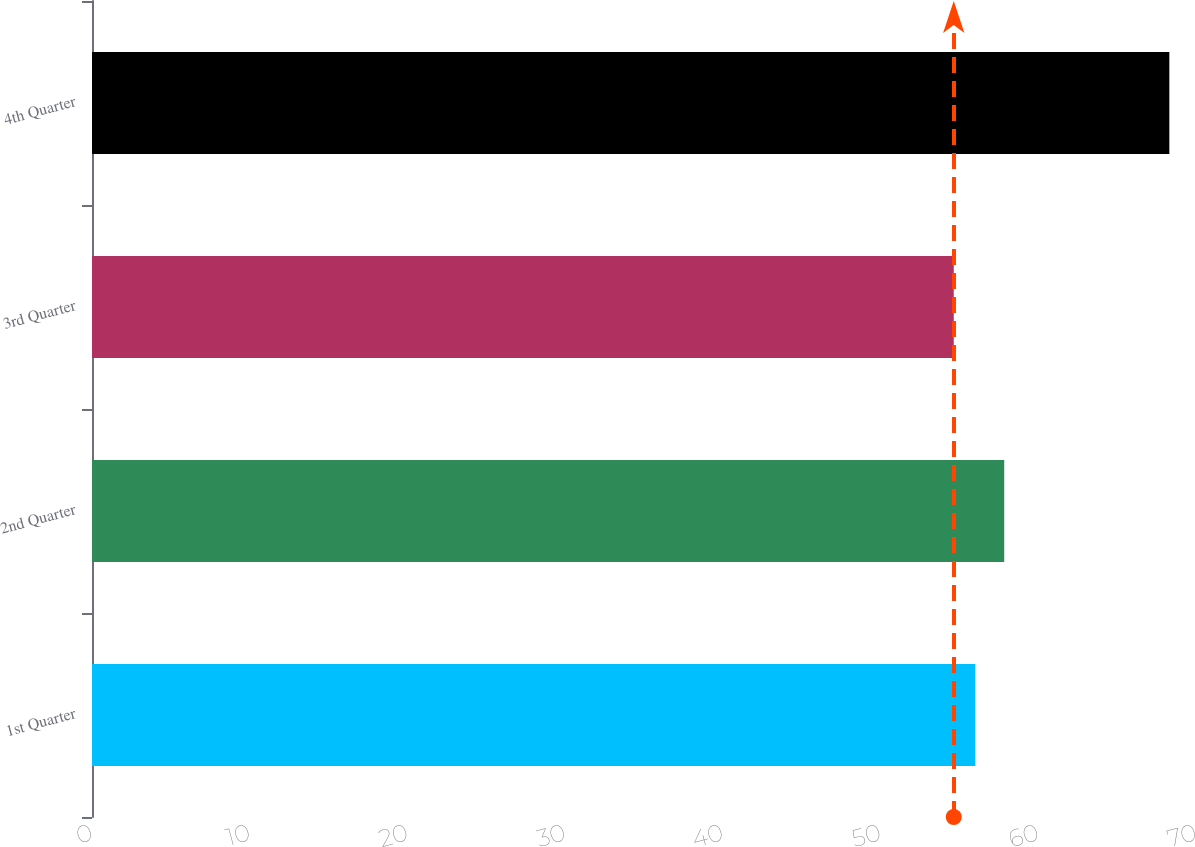Convert chart to OTSL. <chart><loc_0><loc_0><loc_500><loc_500><bar_chart><fcel>1st Quarter<fcel>2nd Quarter<fcel>3rd Quarter<fcel>4th Quarter<nl><fcel>56.01<fcel>57.84<fcel>54.64<fcel>68.31<nl></chart> 